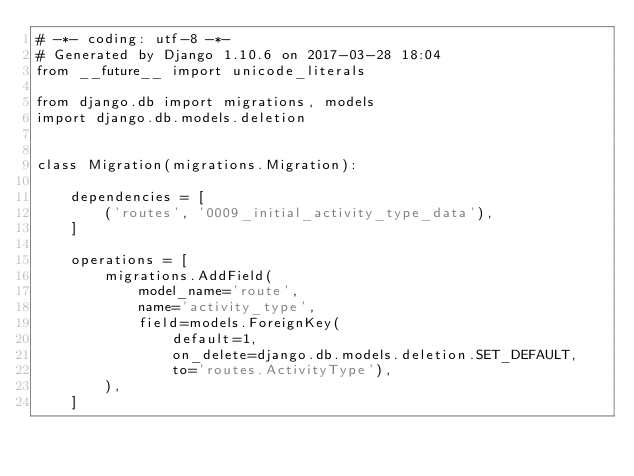<code> <loc_0><loc_0><loc_500><loc_500><_Python_># -*- coding: utf-8 -*-
# Generated by Django 1.10.6 on 2017-03-28 18:04
from __future__ import unicode_literals

from django.db import migrations, models
import django.db.models.deletion


class Migration(migrations.Migration):

    dependencies = [
        ('routes', '0009_initial_activity_type_data'),
    ]

    operations = [
        migrations.AddField(
            model_name='route',
            name='activity_type',
            field=models.ForeignKey(
                default=1,
                on_delete=django.db.models.deletion.SET_DEFAULT,
                to='routes.ActivityType'),
        ),
    ]
</code> 